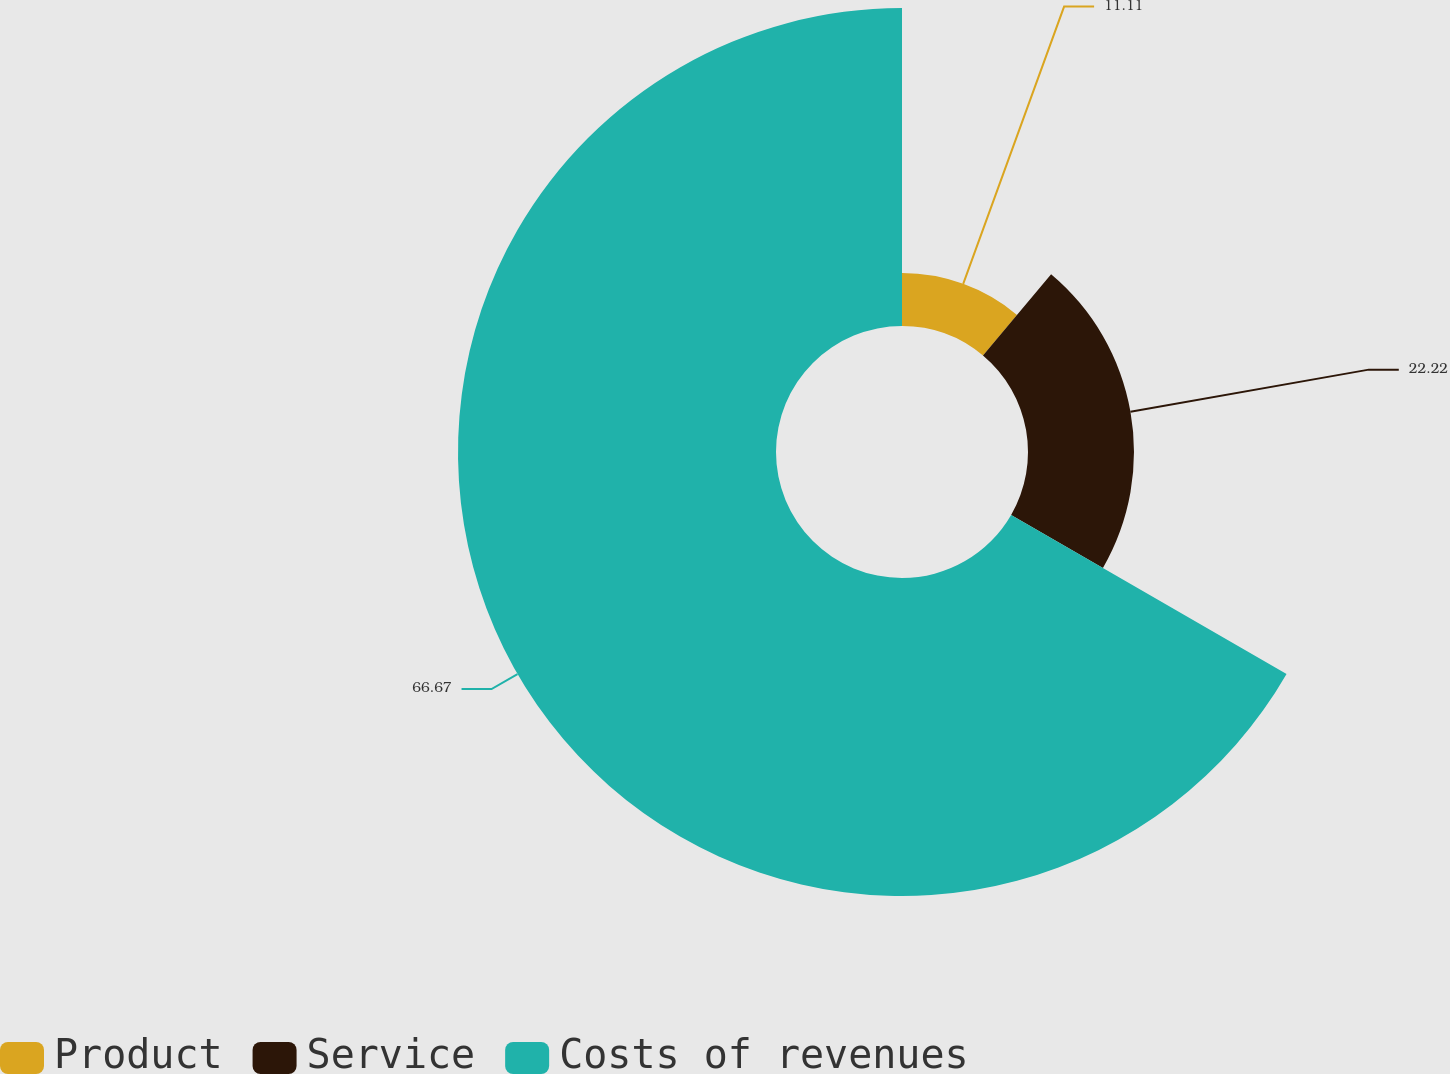<chart> <loc_0><loc_0><loc_500><loc_500><pie_chart><fcel>Product<fcel>Service<fcel>Costs of revenues<nl><fcel>11.11%<fcel>22.22%<fcel>66.67%<nl></chart> 